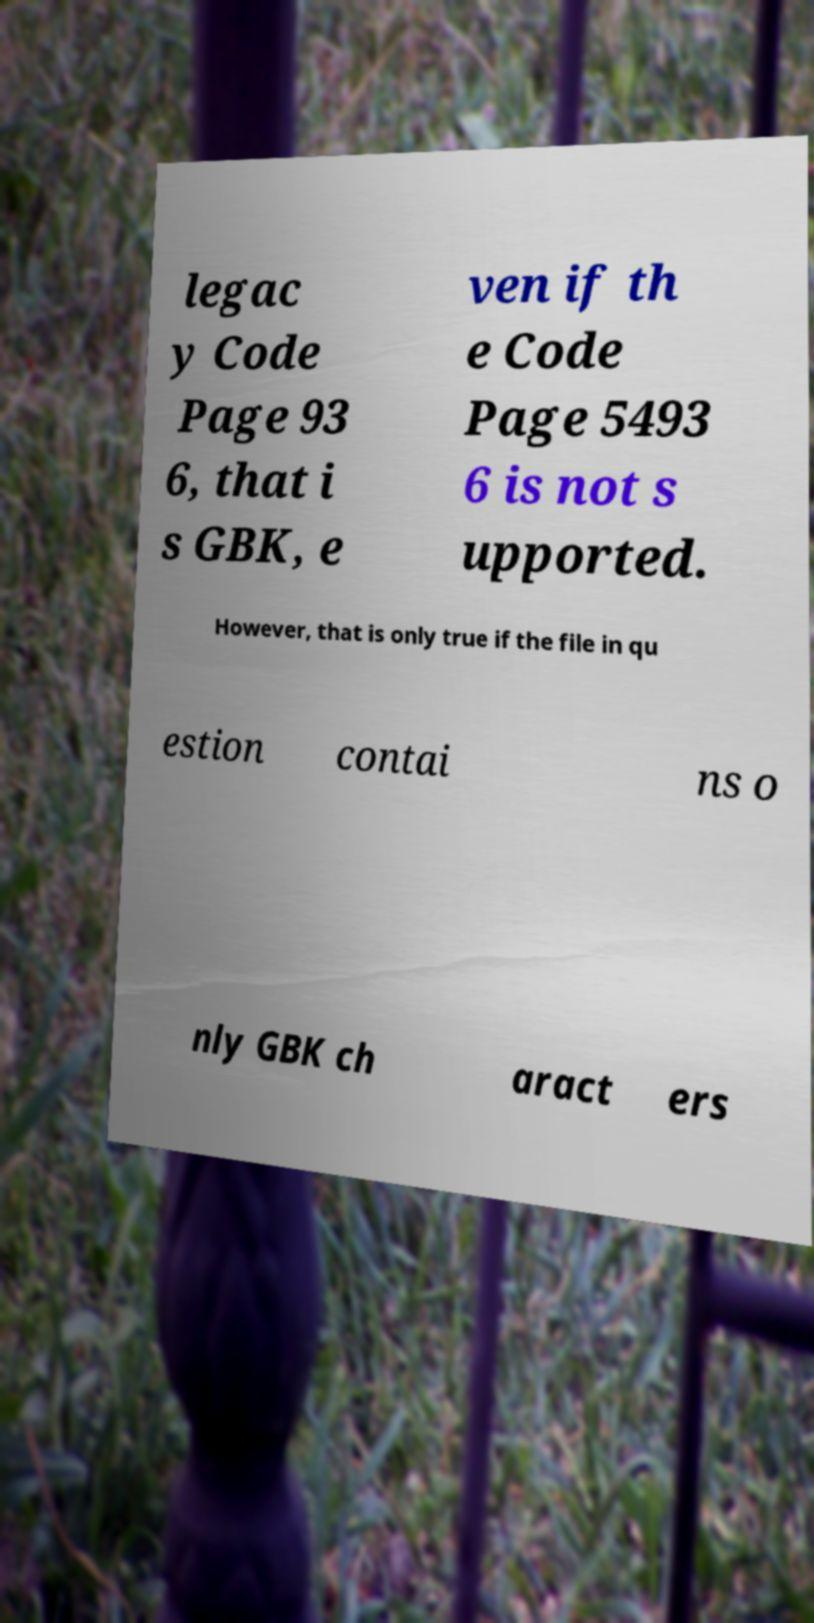I need the written content from this picture converted into text. Can you do that? legac y Code Page 93 6, that i s GBK, e ven if th e Code Page 5493 6 is not s upported. However, that is only true if the file in qu estion contai ns o nly GBK ch aract ers 